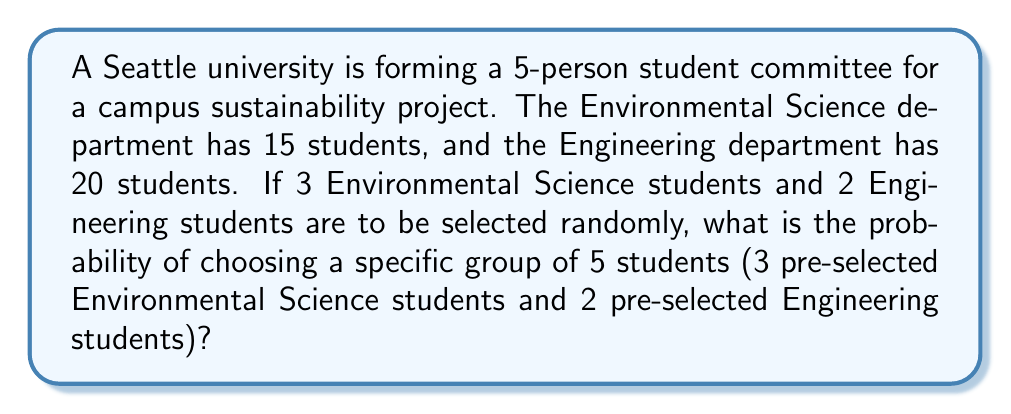Can you answer this question? Let's approach this step-by-step:

1) First, we need to calculate the number of ways to choose 3 students from 15 Environmental Science students:
   $$\binom{15}{3} = \frac{15!}{3!(15-3)!} = \frac{15!}{3!12!} = 455$$

2) Next, we calculate the number of ways to choose 2 students from 20 Engineering students:
   $$\binom{20}{2} = \frac{20!}{2!(20-2)!} = \frac{20!}{2!18!} = 190$$

3) The total number of ways to choose 3 Environmental Science students and 2 Engineering students is:
   $$455 \times 190 = 86,450$$

4) Now, the probability of choosing a specific group of 5 students (3 pre-selected Environmental Science students and 2 pre-selected Engineering students) is 1 out of this total number of possibilities:
   $$P(\text{specific group}) = \frac{1}{86,450}$$

5) To express this as a decimal, we calculate:
   $$\frac{1}{86,450} \approx 0.0000115674$$

This can also be expressed as approximately 1.16 × 10⁻⁵ or about 0.00116%.
Answer: $\frac{1}{86,450}$ or approximately 0.0000115674 